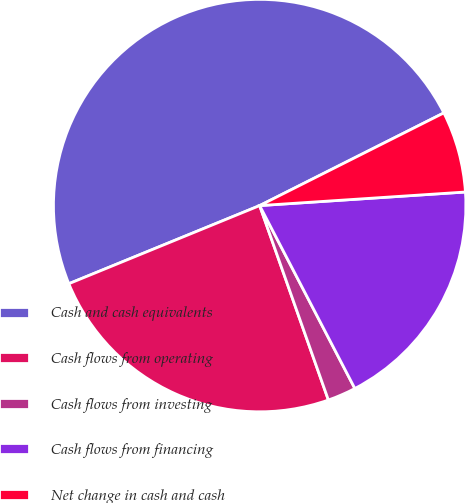Convert chart. <chart><loc_0><loc_0><loc_500><loc_500><pie_chart><fcel>Cash and cash equivalents<fcel>Cash flows from operating<fcel>Cash flows from investing<fcel>Cash flows from financing<fcel>Net change in cash and cash<nl><fcel>48.76%<fcel>24.22%<fcel>2.23%<fcel>18.41%<fcel>6.37%<nl></chart> 